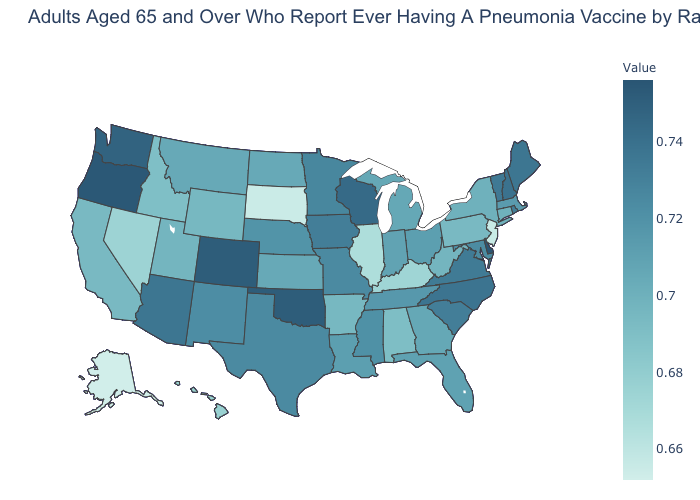Which states have the lowest value in the South?
Short answer required. Kentucky. Which states hav the highest value in the West?
Be succinct. Oregon. Does Washington have the lowest value in the West?
Concise answer only. No. Does Hawaii have the highest value in the West?
Quick response, please. No. Among the states that border Idaho , does Nevada have the lowest value?
Give a very brief answer. Yes. Does Rhode Island have the highest value in the Northeast?
Give a very brief answer. No. Among the states that border Arizona , which have the highest value?
Keep it brief. Colorado. Is the legend a continuous bar?
Keep it brief. Yes. Among the states that border Delaware , which have the highest value?
Be succinct. Maryland. 